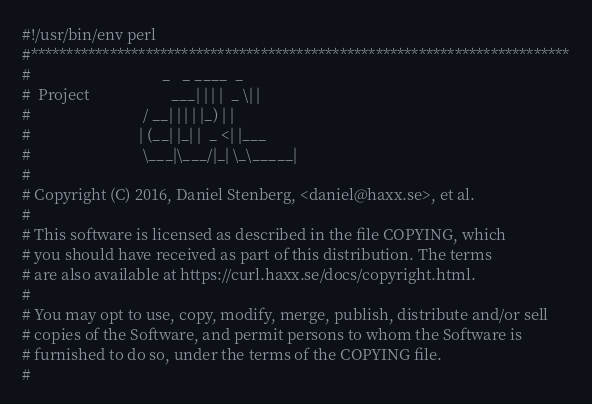Convert code to text. <code><loc_0><loc_0><loc_500><loc_500><_Perl_>#!/usr/bin/env perl
#***************************************************************************
#                                  _   _ ____  _
#  Project                     ___| | | |  _ \| |
#                             / __| | | | |_) | |
#                            | (__| |_| |  _ <| |___
#                             \___|\___/|_| \_\_____|
#
# Copyright (C) 2016, Daniel Stenberg, <daniel@haxx.se>, et al.
#
# This software is licensed as described in the file COPYING, which
# you should have received as part of this distribution. The terms
# are also available at https://curl.haxx.se/docs/copyright.html.
#
# You may opt to use, copy, modify, merge, publish, distribute and/or sell
# copies of the Software, and permit persons to whom the Software is
# furnished to do so, under the terms of the COPYING file.
#</code> 